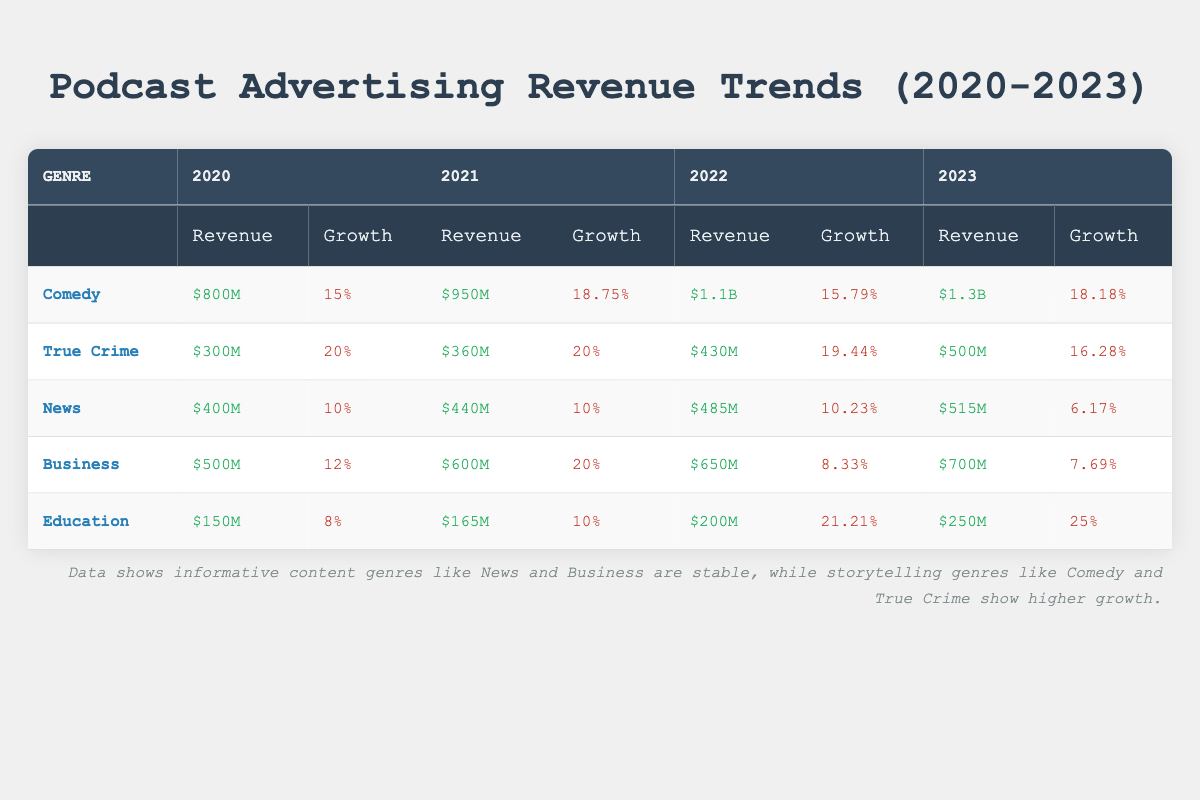What was the podcast advertising revenue for True Crime in 2022? According to the table, the revenue listed for True Crime in 2022 is $430M.
Answer: $430M What genre had the highest revenue in 2023? By examining the table, I can see the revenue for Comedy in 2023 is $1.3B, which is the highest among all genres listed.
Answer: Comedy What was the average revenue growth rate for Education from 2020 to 2023? The growth rates for Education are 8%, 10%, 21.21%, and 25%. Adding these up gives (8 + 10 + 21.21 + 25) = 64.21. Then, dividing by 4 (the number of years) gives 64.21 / 4 = 16.0525.
Answer: 16.05% Did the revenue for Business increase every year from 2020 to 2023? Looking closely at the table, I see that revenue for Business went from $500M in 2020 to $700M in 2023, showing an increase every year with the values being $600M in 2021 and $650M in 2022. Therefore, the statement is true.
Answer: Yes Which genre showed the largest increase in revenue from 2020 to 2023? To determine this, I compare the revenue figures for each genre in 2020 and 2023. Comedy increased from $800M to $1.3B, a change of $500M. True Crime went from $300M to $500M, an increase of $200M. Comparing these increases, Comedy had the largest increase of $500M.
Answer: Comedy 